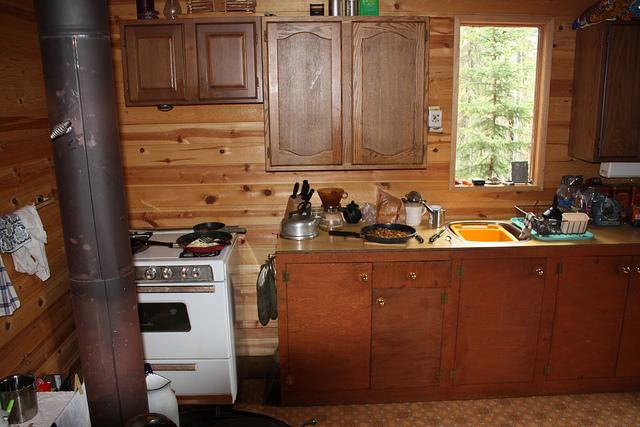What is the wall made of?
Short answer required. Wood. How many towels are shown?
Give a very brief answer. 3. Where is the kettle?
Keep it brief. Counter. Why is there so much wood throughout this house?
Short answer required. Cabin. Does the pan look dirty?
Concise answer only. Yes. Is the stove white?
Concise answer only. Yes. Is this the kitchen?
Short answer required. Yes. What kind of stove is pictured?
Answer briefly. Gas. 